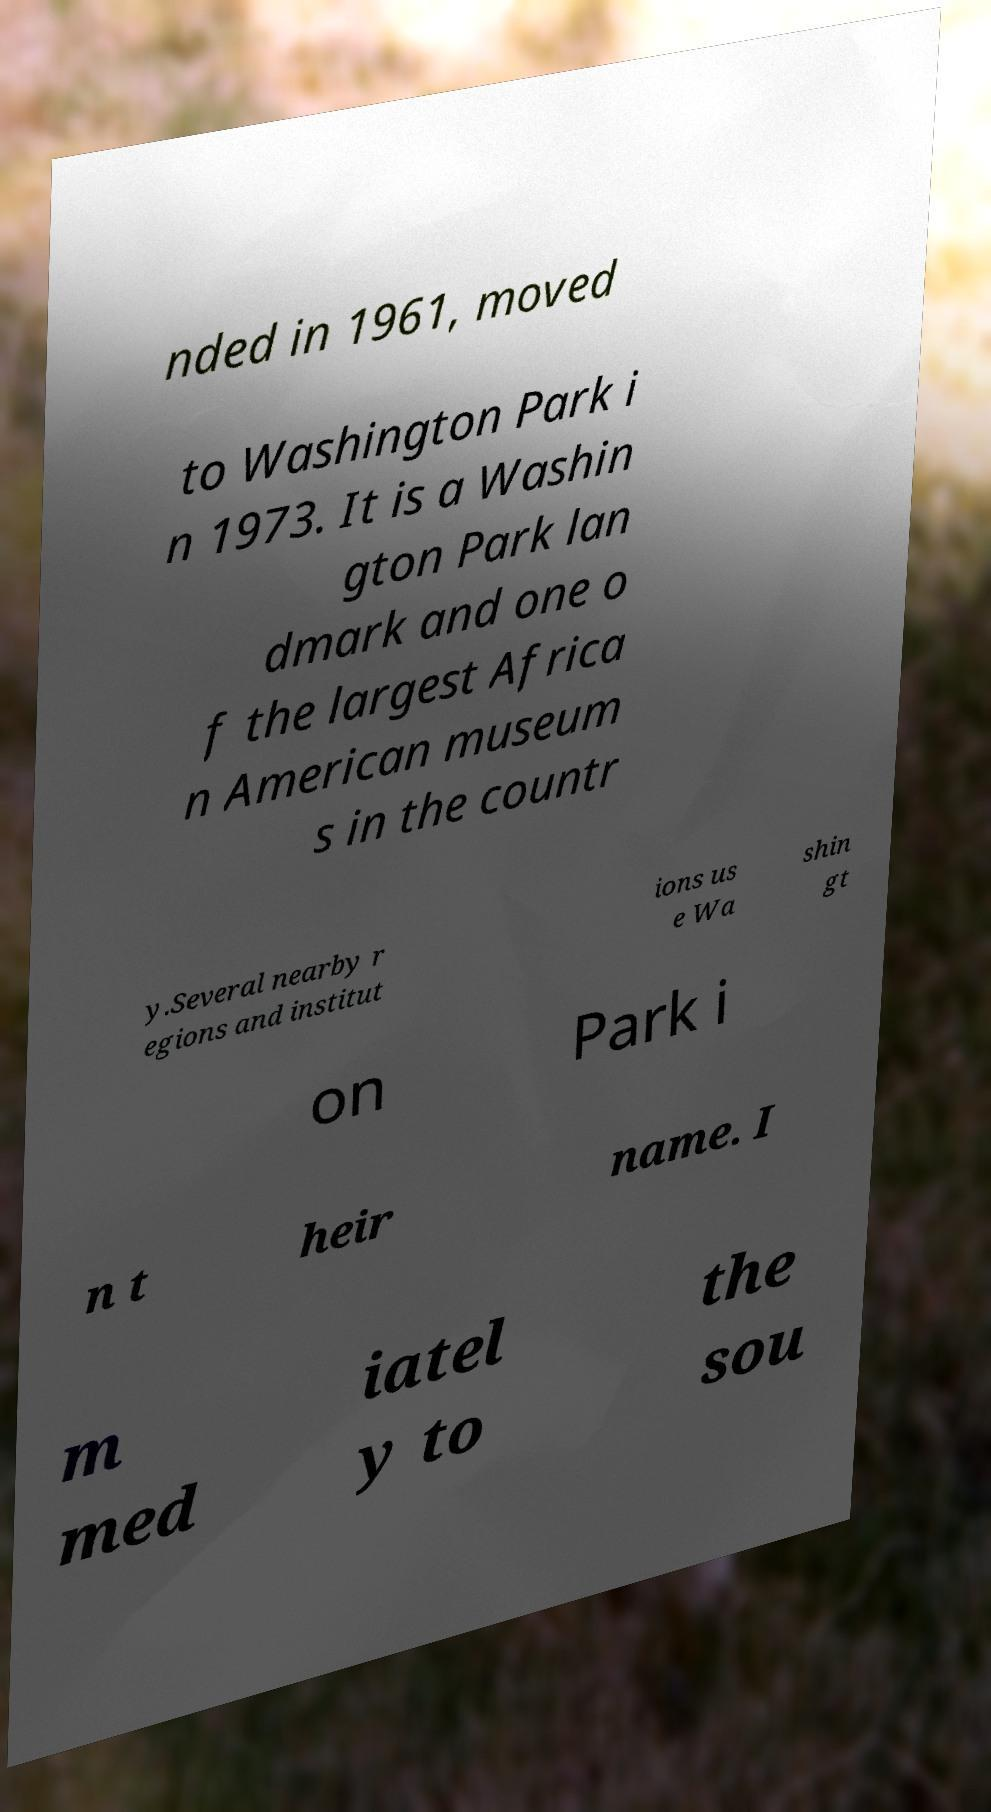Can you read and provide the text displayed in the image?This photo seems to have some interesting text. Can you extract and type it out for me? nded in 1961, moved to Washington Park i n 1973. It is a Washin gton Park lan dmark and one o f the largest Africa n American museum s in the countr y.Several nearby r egions and institut ions us e Wa shin gt on Park i n t heir name. I m med iatel y to the sou 